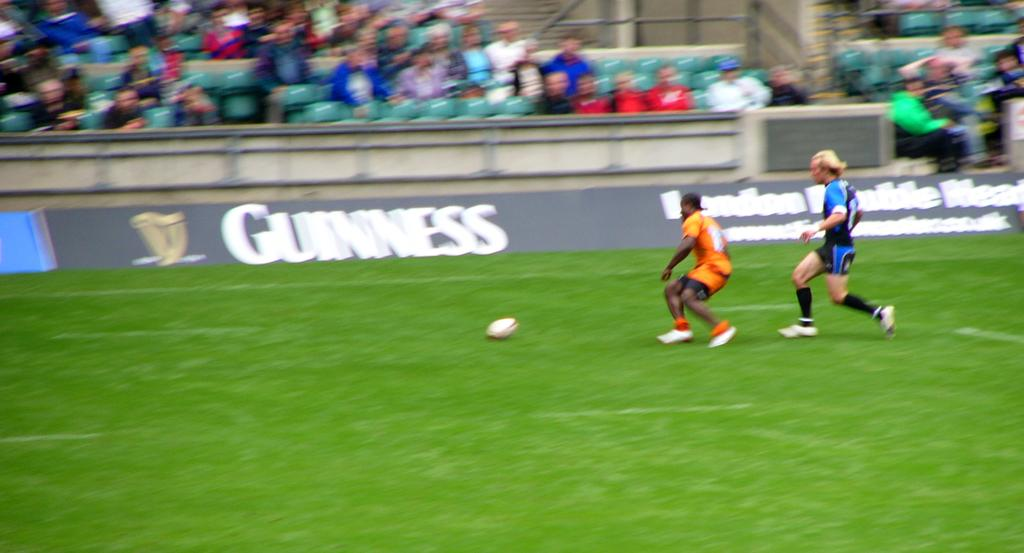<image>
Write a terse but informative summary of the picture. A Guinness banner ad is prominently displayed on a soccer field's sideline. 